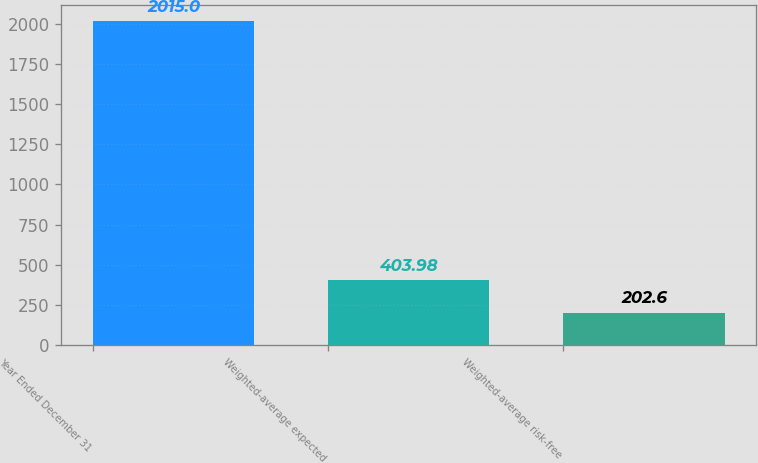<chart> <loc_0><loc_0><loc_500><loc_500><bar_chart><fcel>Year Ended December 31<fcel>Weighted-average expected<fcel>Weighted-average risk-free<nl><fcel>2015<fcel>403.98<fcel>202.6<nl></chart> 